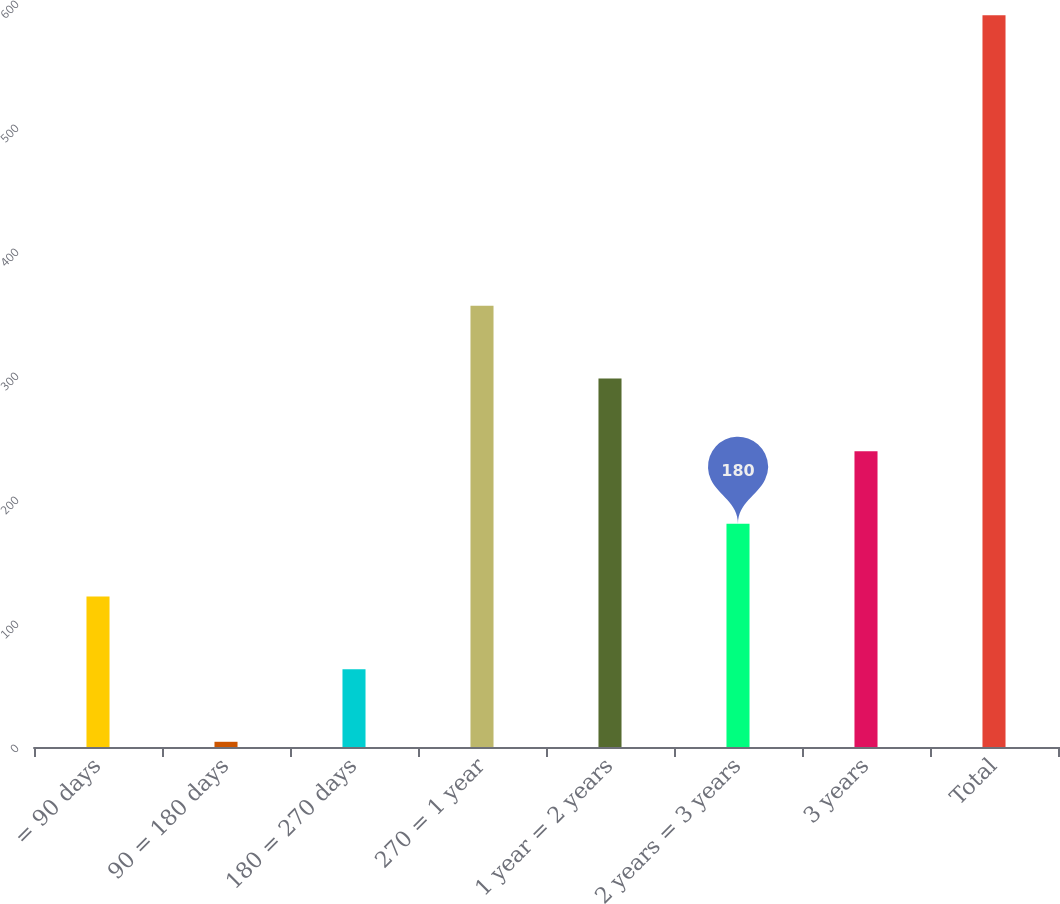Convert chart to OTSL. <chart><loc_0><loc_0><loc_500><loc_500><bar_chart><fcel>= 90 days<fcel>90 = 180 days<fcel>180 = 270 days<fcel>270 = 1 year<fcel>1 year = 2 years<fcel>2 years = 3 years<fcel>3 years<fcel>Total<nl><fcel>121.4<fcel>4.2<fcel>62.8<fcel>355.8<fcel>297.2<fcel>180<fcel>238.6<fcel>590.2<nl></chart> 